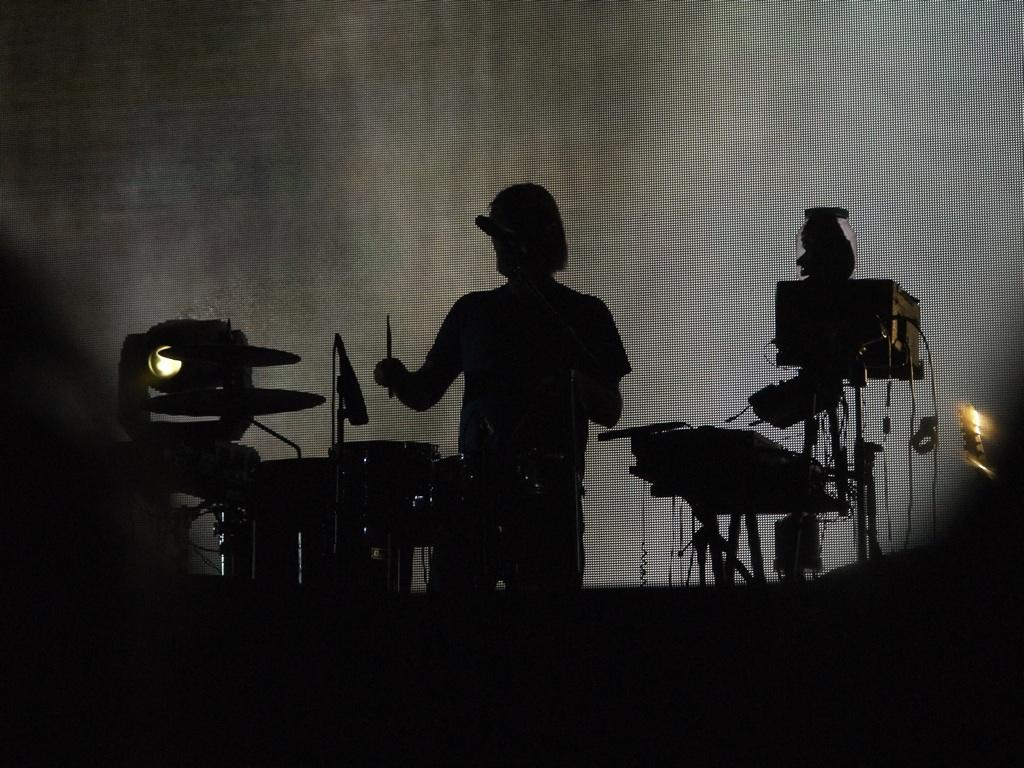What is the overall lighting condition in the image? The image is dark. Can you describe the person in the image? There is a person standing in the image, and they are holding a stick. What equipment can be seen in the image? There is a microphone with a stand, devices, a musical instrument, and a light present in the image. Are there any cables visible in the image? Yes, there are cables visible in the image. What is the weather like in the image? The provided facts do not mention the weather, so we cannot determine the weather from the image. Is there any air conditioning visible in the image? There is no mention of air conditioning in the provided facts, so we cannot determine if it is present in the image. 